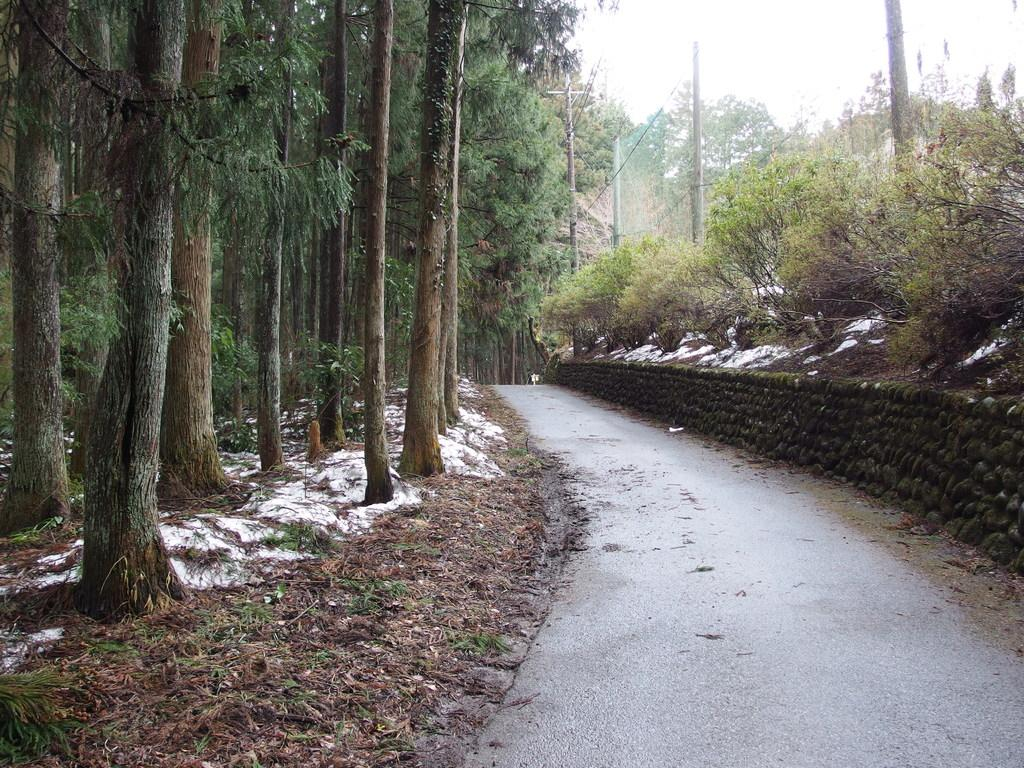What type of vegetation can be seen in the image? There are trees in the image. What man-made structures are present in the image? Electric poles are present in the image. What is connected to the electric poles in the image? Electric cables are visible in the image. What is the weather like in the image? There is snow in the image. What is on the ground in the image? Shredded leaves are on the ground in the image. What type of pathway is visible in the image? There is a road in the image. What is visible above the trees and structures in the image? The sky is visible in the image. What type of stamp can be seen on the trees in the image? There are no stamps present on the trees in the image. How does the steam rise from the electric cables in the image? There is no steam present in the image; it is not a weather condition or a byproduct of the electric cables. 